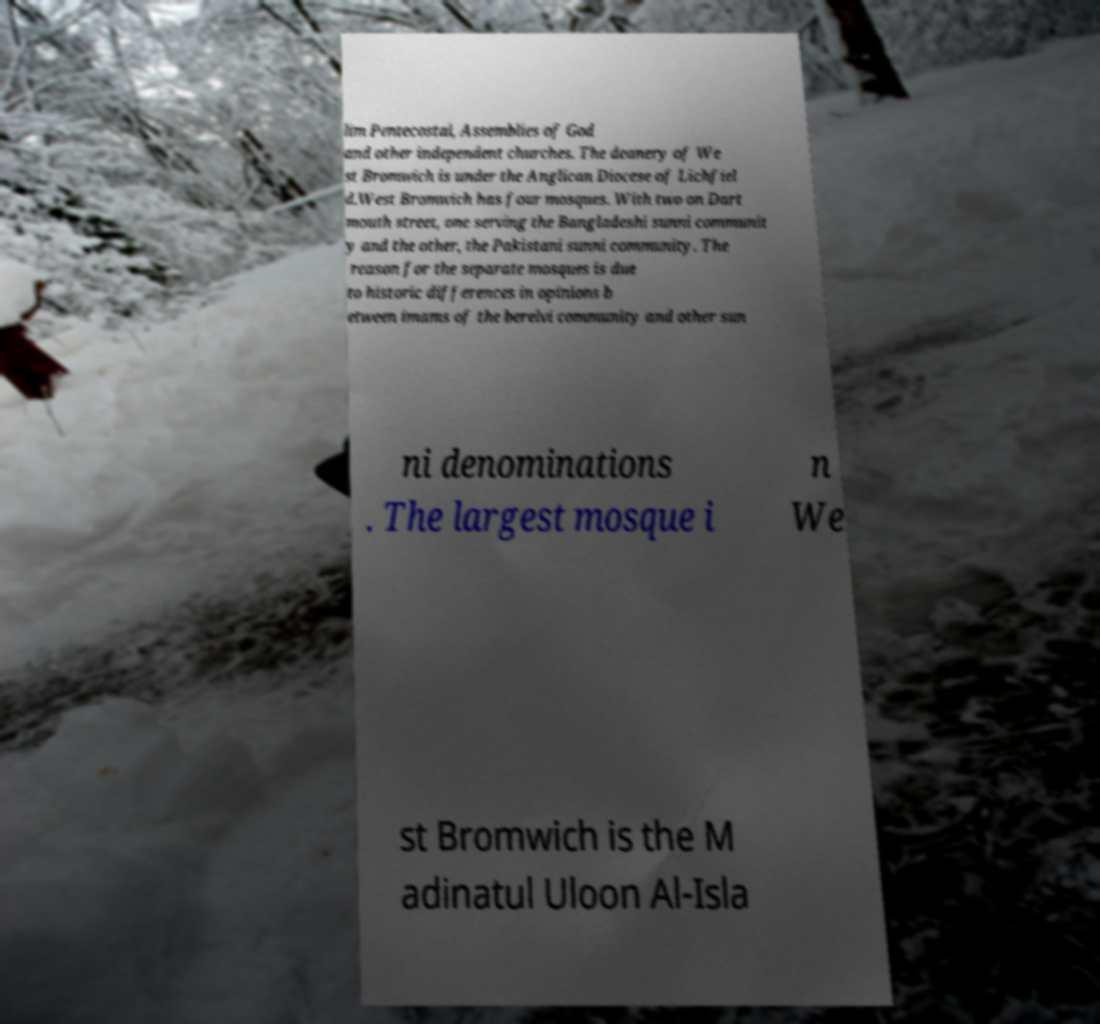Could you extract and type out the text from this image? lim Pentecostal, Assemblies of God and other independent churches. The deanery of We st Bromwich is under the Anglican Diocese of Lichfiel d.West Bromwich has four mosques. With two on Dart mouth street, one serving the Bangladeshi sunni communit y and the other, the Pakistani sunni community. The reason for the separate mosques is due to historic differences in opinions b etween imams of the berelvi community and other sun ni denominations . The largest mosque i n We st Bromwich is the M adinatul Uloon Al-Isla 